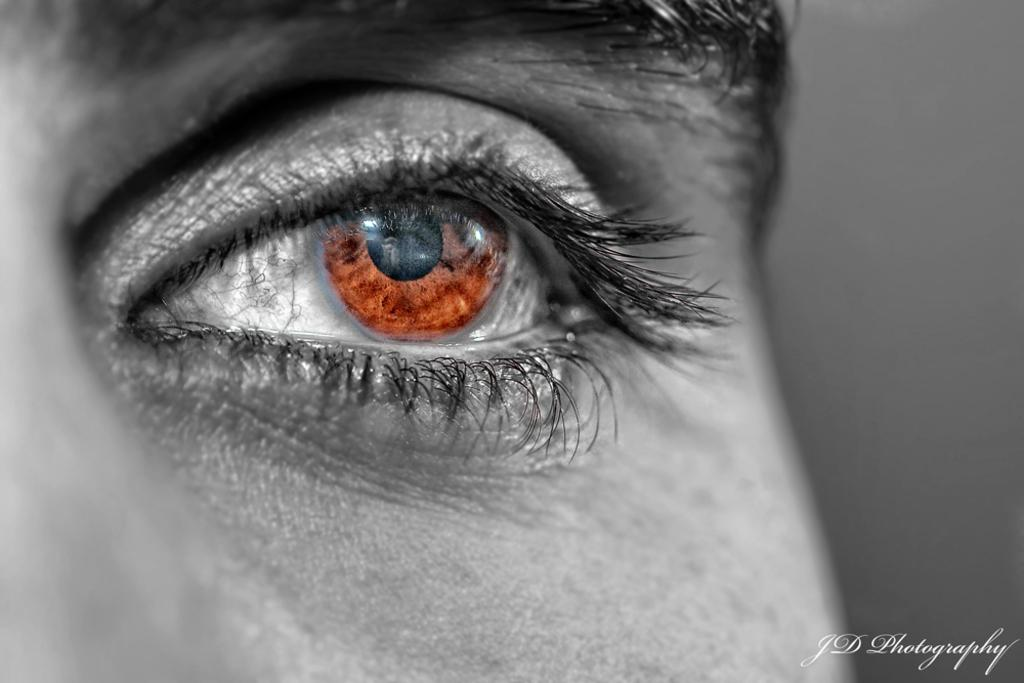What is the main subject in the image? There is a person (truncated) in the image. What can be found at the bottom of the image? There is text at the bottom of the image. What is visible in the background of the image? There is a wall in the background of the image. How many planes can be seen flying over the wall in the image? There are no planes visible in the image; it only features a person (truncated), text at the bottom, and a wall in the background. 